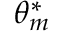Convert formula to latex. <formula><loc_0><loc_0><loc_500><loc_500>\theta _ { m } ^ { * }</formula> 